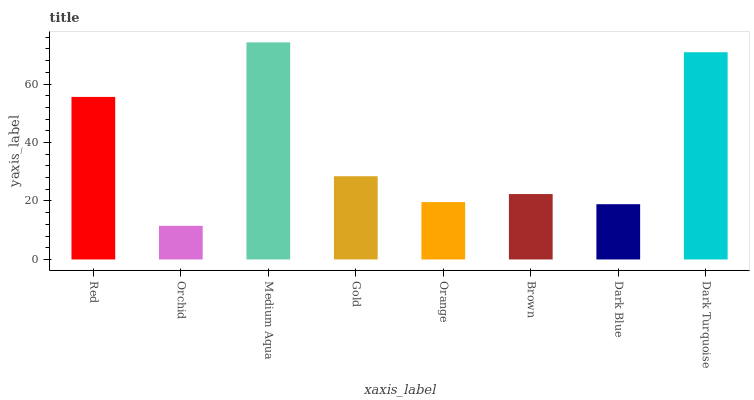Is Medium Aqua the minimum?
Answer yes or no. No. Is Orchid the maximum?
Answer yes or no. No. Is Medium Aqua greater than Orchid?
Answer yes or no. Yes. Is Orchid less than Medium Aqua?
Answer yes or no. Yes. Is Orchid greater than Medium Aqua?
Answer yes or no. No. Is Medium Aqua less than Orchid?
Answer yes or no. No. Is Gold the high median?
Answer yes or no. Yes. Is Brown the low median?
Answer yes or no. Yes. Is Dark Blue the high median?
Answer yes or no. No. Is Orchid the low median?
Answer yes or no. No. 